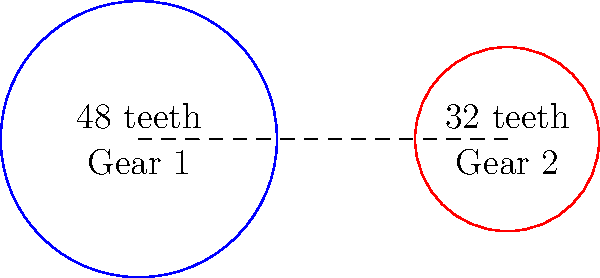In a simple gear train system used in a prototype at the Institute of Mathematics, Physics and Computer Science at Aberystwyth University, Gear 1 has 48 teeth and Gear 2 has 32 teeth. If Gear 1 rotates at 120 rpm clockwise, calculate the speed and direction of Gear 2. What is the efficiency of this gear train if the power input is 5 kW and the power output is 4.8 kW? Let's approach this step-by-step:

1. Speed ratio calculation:
   The speed ratio is inversely proportional to the number of teeth.
   $$\frac{\text{Speed of Gear 2}}{\text{Speed of Gear 1}} = \frac{\text{Number of teeth on Gear 1}}{\text{Number of teeth on Gear 2}}$$
   $$\frac{\text{Speed of Gear 2}}{120 \text{ rpm}} = \frac{48}{32}$$
   $$\text{Speed of Gear 2} = 120 \times \frac{48}{32} = 180 \text{ rpm}$$

2. Direction of Gear 2:
   In a simple gear train, adjacent gears rotate in opposite directions. Since Gear 1 rotates clockwise, Gear 2 will rotate counterclockwise.

3. Efficiency calculation:
   Efficiency is the ratio of power output to power input, expressed as a percentage.
   $$\text{Efficiency} = \frac{\text{Power Output}}{\text{Power Input}} \times 100\%$$
   $$\text{Efficiency} = \frac{4.8 \text{ kW}}{5 \text{ kW}} \times 100\% = 96\%$$
Answer: 180 rpm counterclockwise, 96% efficient 